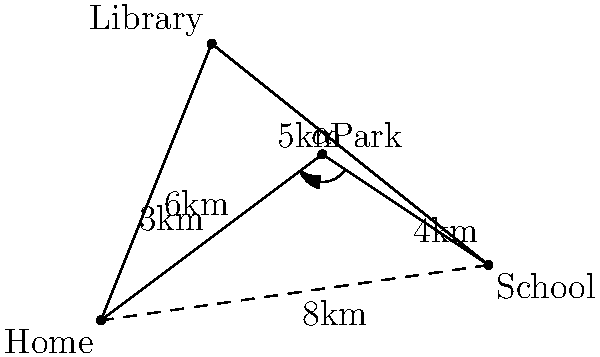A mother is planning the safest route for her child from home to school. The neighborhood map shows four locations: Home, School, Park, and Library. The direct path from Home to School is 8km long. If the child goes through the Park, the total distance is 7km (3km from Home to Park, and 4km from Park to School). The angle $\alpha$ at the Park between the Home-Park and Park-School paths is 120°. How much shorter is the direct path compared to the path through the Park? Let's approach this step-by-step:

1) We are given:
   - Direct path from Home to School = 8km
   - Path through Park: Home to Park = 3km, Park to School = 4km
   - Angle at Park ($\alpha$) = 120°

2) To find the difference, we need to:
   a) Calculate the total distance of the path through the Park
   b) Subtract the direct path distance from this

3) The total distance of the path through the Park is already given:
   3km + 4km = 7km

4) Now, we can calculate the difference:
   Path through Park - Direct path = 7km - 8km = -1km

5) The negative result indicates that the direct path is shorter.

6) To express how much shorter the direct path is, we take the absolute value:
   |7km - 8km| = 1km

Therefore, the direct path is 1km shorter than the path through the Park.
Answer: 1km 